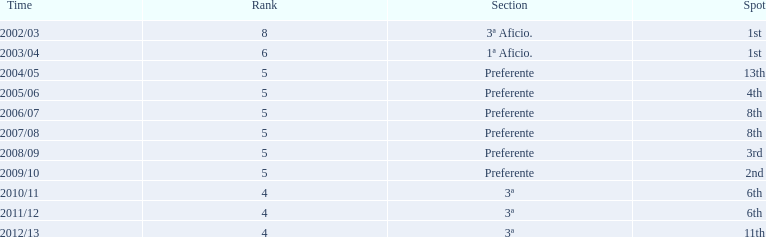How long has internacional de madrid cf been playing in the 3ª division? 3. 